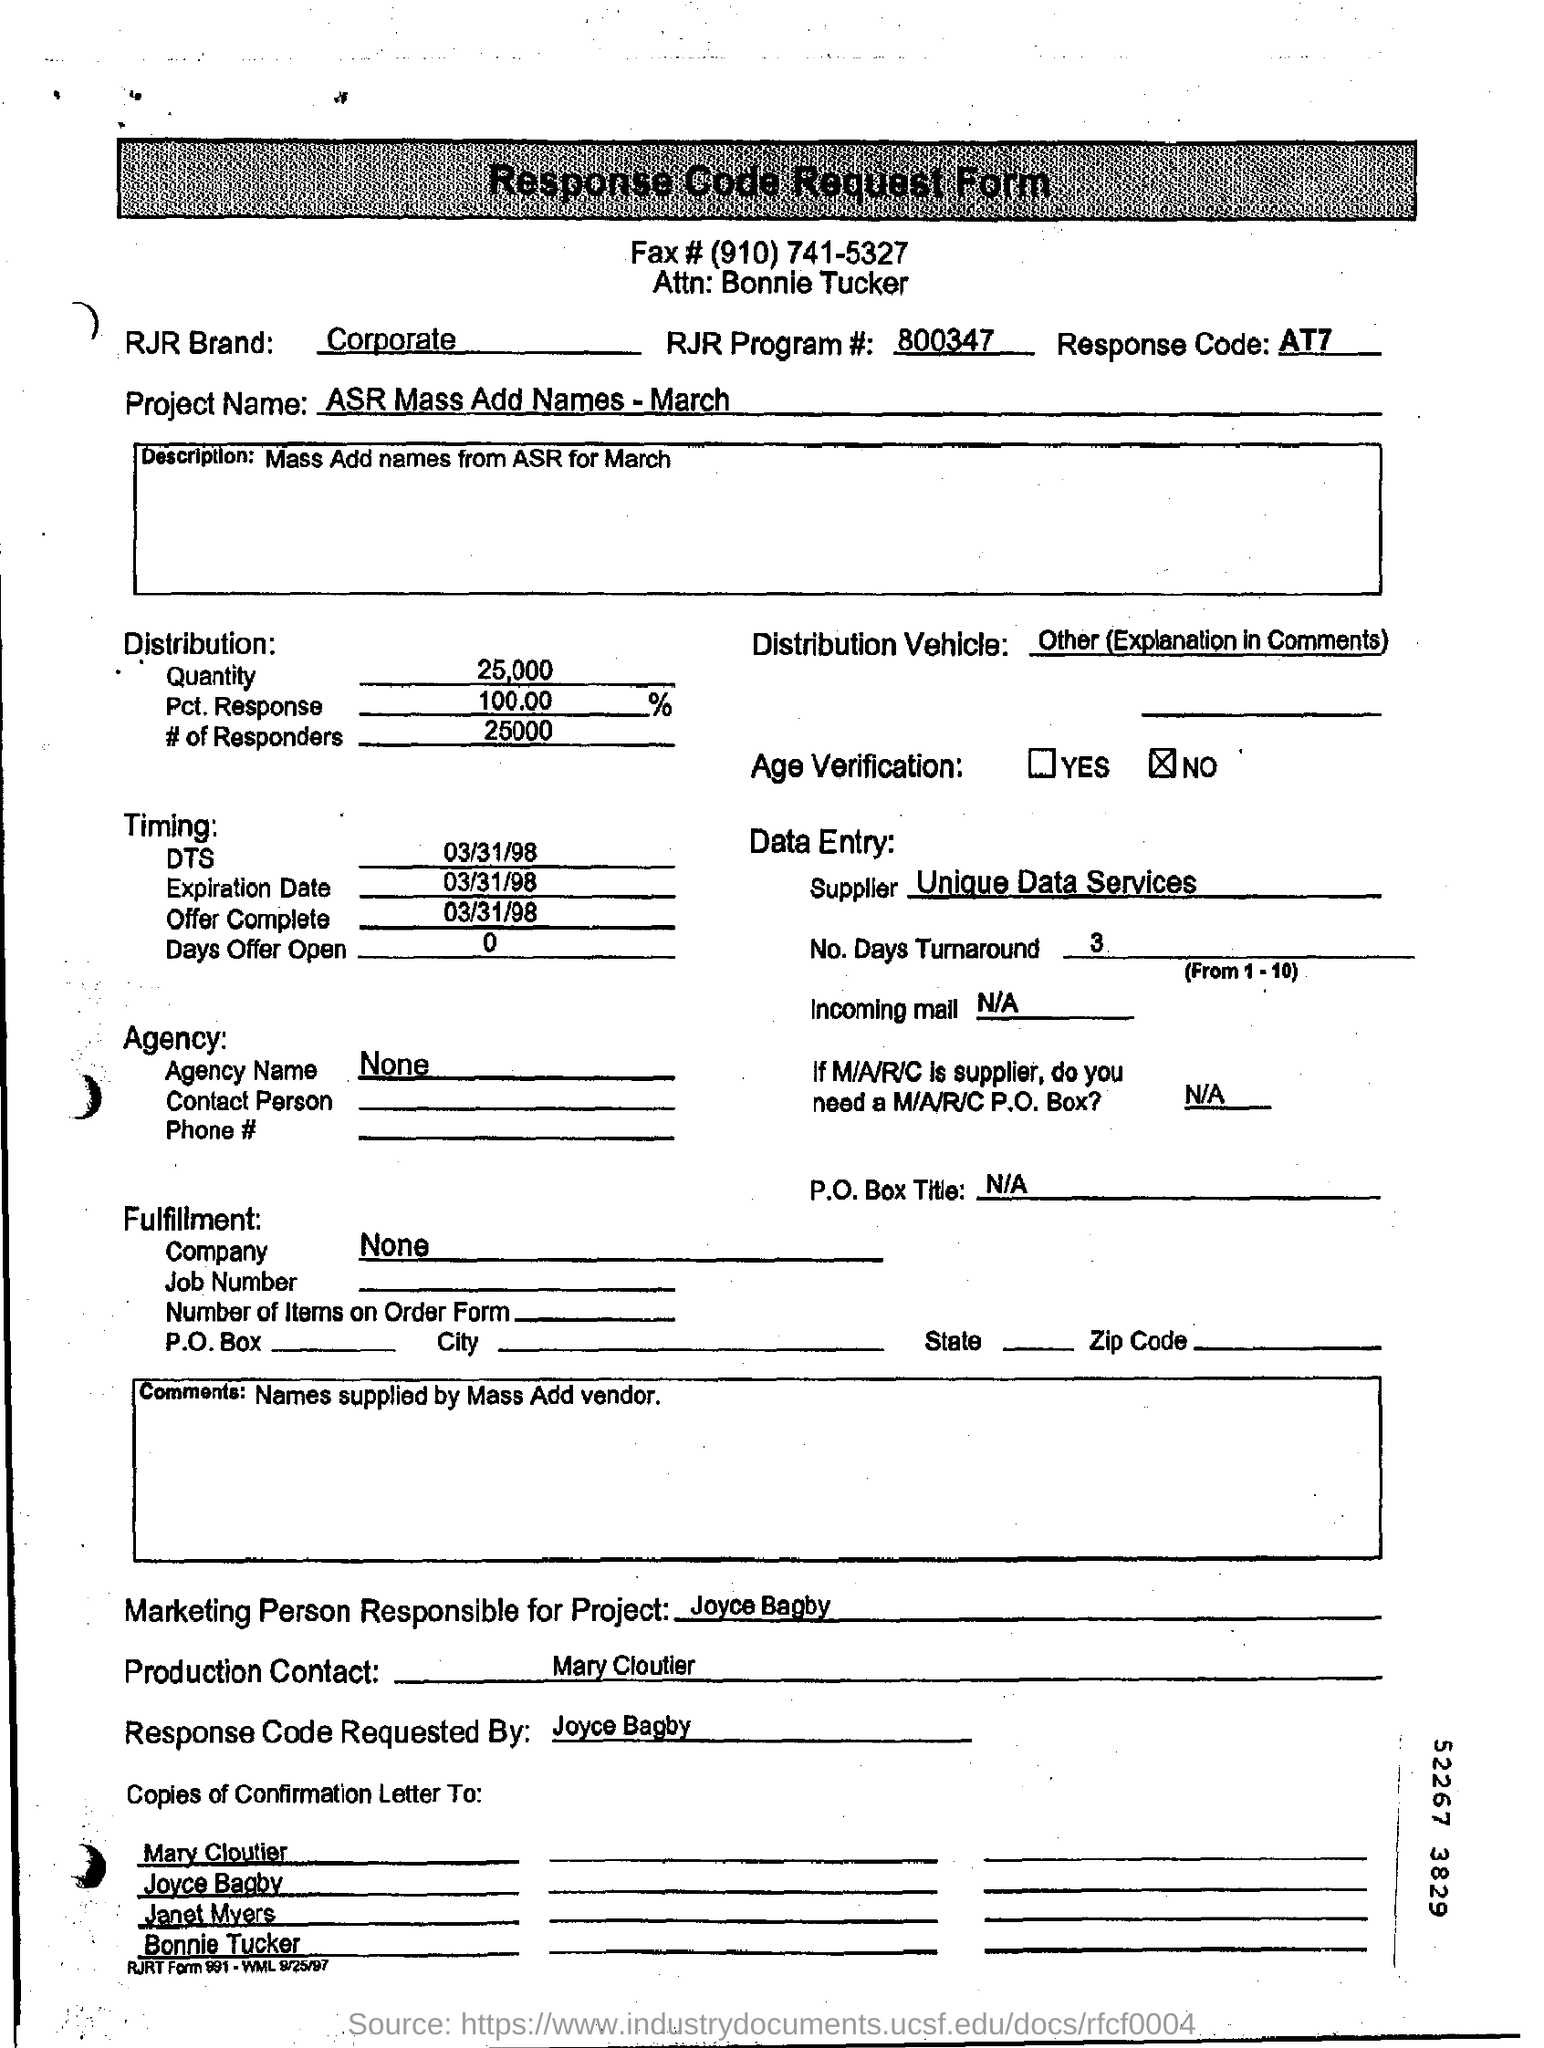Outline some significant characteristics in this image. The response code mentioned is AT7. The expiration date is March 31, 1998. The Comments section of the form provides information that is supplied by Mass Add vendor, which includes names. The project name is ASR Mass Add Names - March. The Production contact is Mary Cloutier. 